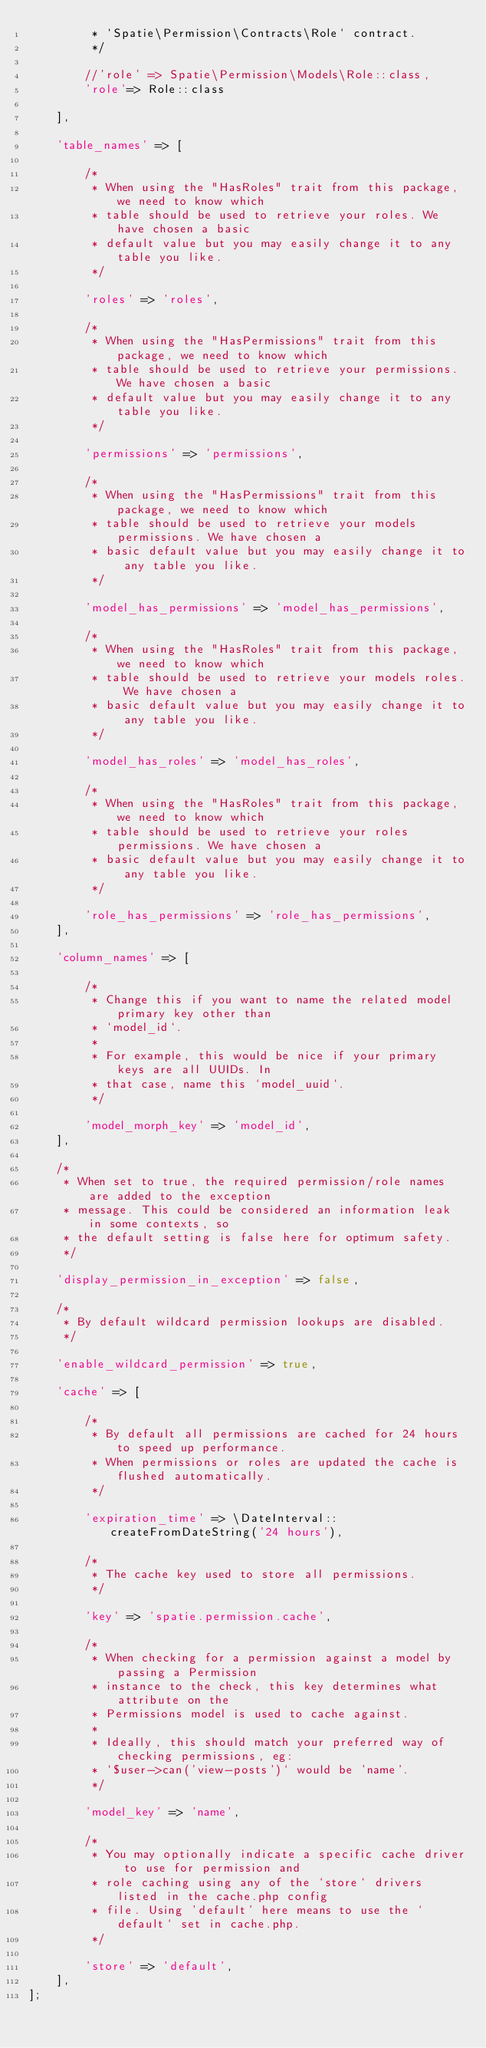<code> <loc_0><loc_0><loc_500><loc_500><_PHP_>         * `Spatie\Permission\Contracts\Role` contract.
         */

        //'role' => Spatie\Permission\Models\Role::class,
        'role'=> Role::class

    ],

    'table_names' => [

        /*
         * When using the "HasRoles" trait from this package, we need to know which
         * table should be used to retrieve your roles. We have chosen a basic
         * default value but you may easily change it to any table you like.
         */

        'roles' => 'roles',

        /*
         * When using the "HasPermissions" trait from this package, we need to know which
         * table should be used to retrieve your permissions. We have chosen a basic
         * default value but you may easily change it to any table you like.
         */

        'permissions' => 'permissions',

        /*
         * When using the "HasPermissions" trait from this package, we need to know which
         * table should be used to retrieve your models permissions. We have chosen a
         * basic default value but you may easily change it to any table you like.
         */

        'model_has_permissions' => 'model_has_permissions',

        /*
         * When using the "HasRoles" trait from this package, we need to know which
         * table should be used to retrieve your models roles. We have chosen a
         * basic default value but you may easily change it to any table you like.
         */

        'model_has_roles' => 'model_has_roles',

        /*
         * When using the "HasRoles" trait from this package, we need to know which
         * table should be used to retrieve your roles permissions. We have chosen a
         * basic default value but you may easily change it to any table you like.
         */

        'role_has_permissions' => 'role_has_permissions',
    ],

    'column_names' => [

        /*
         * Change this if you want to name the related model primary key other than
         * `model_id`.
         *
         * For example, this would be nice if your primary keys are all UUIDs. In
         * that case, name this `model_uuid`.
         */

        'model_morph_key' => 'model_id',
    ],

    /*
     * When set to true, the required permission/role names are added to the exception
     * message. This could be considered an information leak in some contexts, so
     * the default setting is false here for optimum safety.
     */

    'display_permission_in_exception' => false,

    /*
     * By default wildcard permission lookups are disabled.
     */

    'enable_wildcard_permission' => true,

    'cache' => [

        /*
         * By default all permissions are cached for 24 hours to speed up performance.
         * When permissions or roles are updated the cache is flushed automatically.
         */

        'expiration_time' => \DateInterval::createFromDateString('24 hours'),

        /*
         * The cache key used to store all permissions.
         */

        'key' => 'spatie.permission.cache',

        /*
         * When checking for a permission against a model by passing a Permission
         * instance to the check, this key determines what attribute on the
         * Permissions model is used to cache against.
         *
         * Ideally, this should match your preferred way of checking permissions, eg:
         * `$user->can('view-posts')` would be 'name'.
         */

        'model_key' => 'name',

        /*
         * You may optionally indicate a specific cache driver to use for permission and
         * role caching using any of the `store` drivers listed in the cache.php config
         * file. Using 'default' here means to use the `default` set in cache.php.
         */

        'store' => 'default',
    ],
];
</code> 